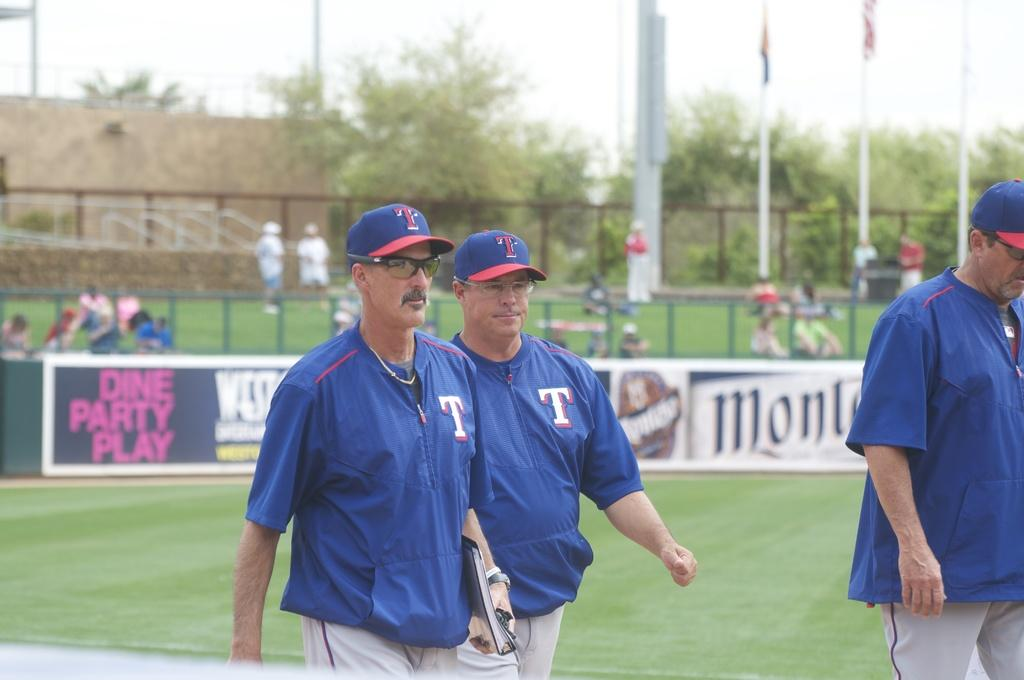Provide a one-sentence caption for the provided image. Baseball player work away from a sign that says dine party play. 